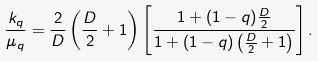Convert formula to latex. <formula><loc_0><loc_0><loc_500><loc_500>\frac { k _ { q } } { \mu _ { q } } = \frac { 2 } { D } \left ( \frac { D } { 2 } + 1 \right ) \left [ \frac { 1 + ( 1 - q ) \frac { D } { 2 } } { 1 + ( 1 - q ) \left ( \frac { D } { 2 } + 1 \right ) } \right ] .</formula> 